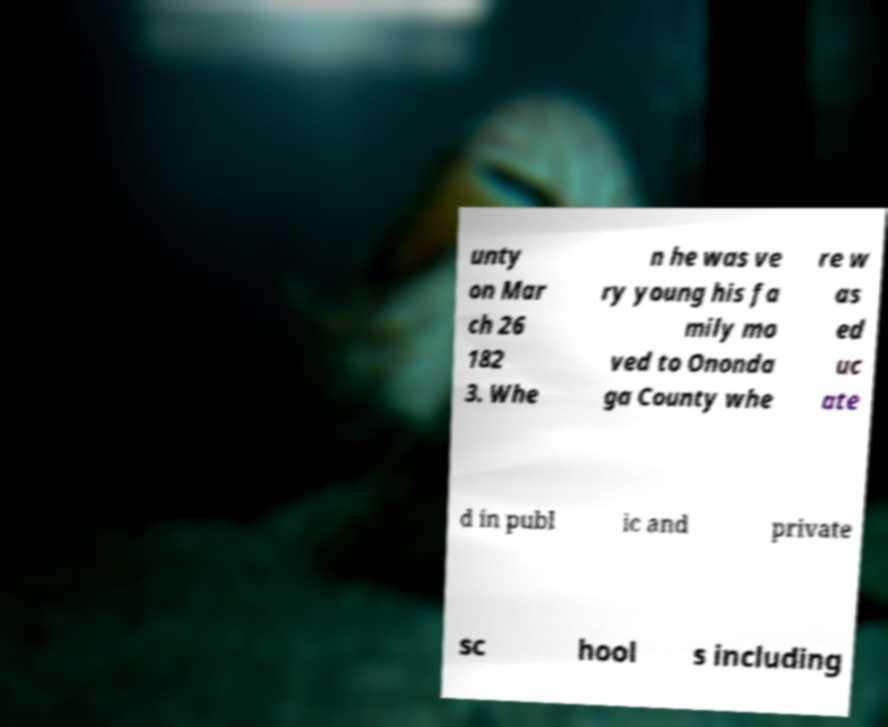There's text embedded in this image that I need extracted. Can you transcribe it verbatim? unty on Mar ch 26 182 3. Whe n he was ve ry young his fa mily mo ved to Ononda ga County whe re w as ed uc ate d in publ ic and private sc hool s including 